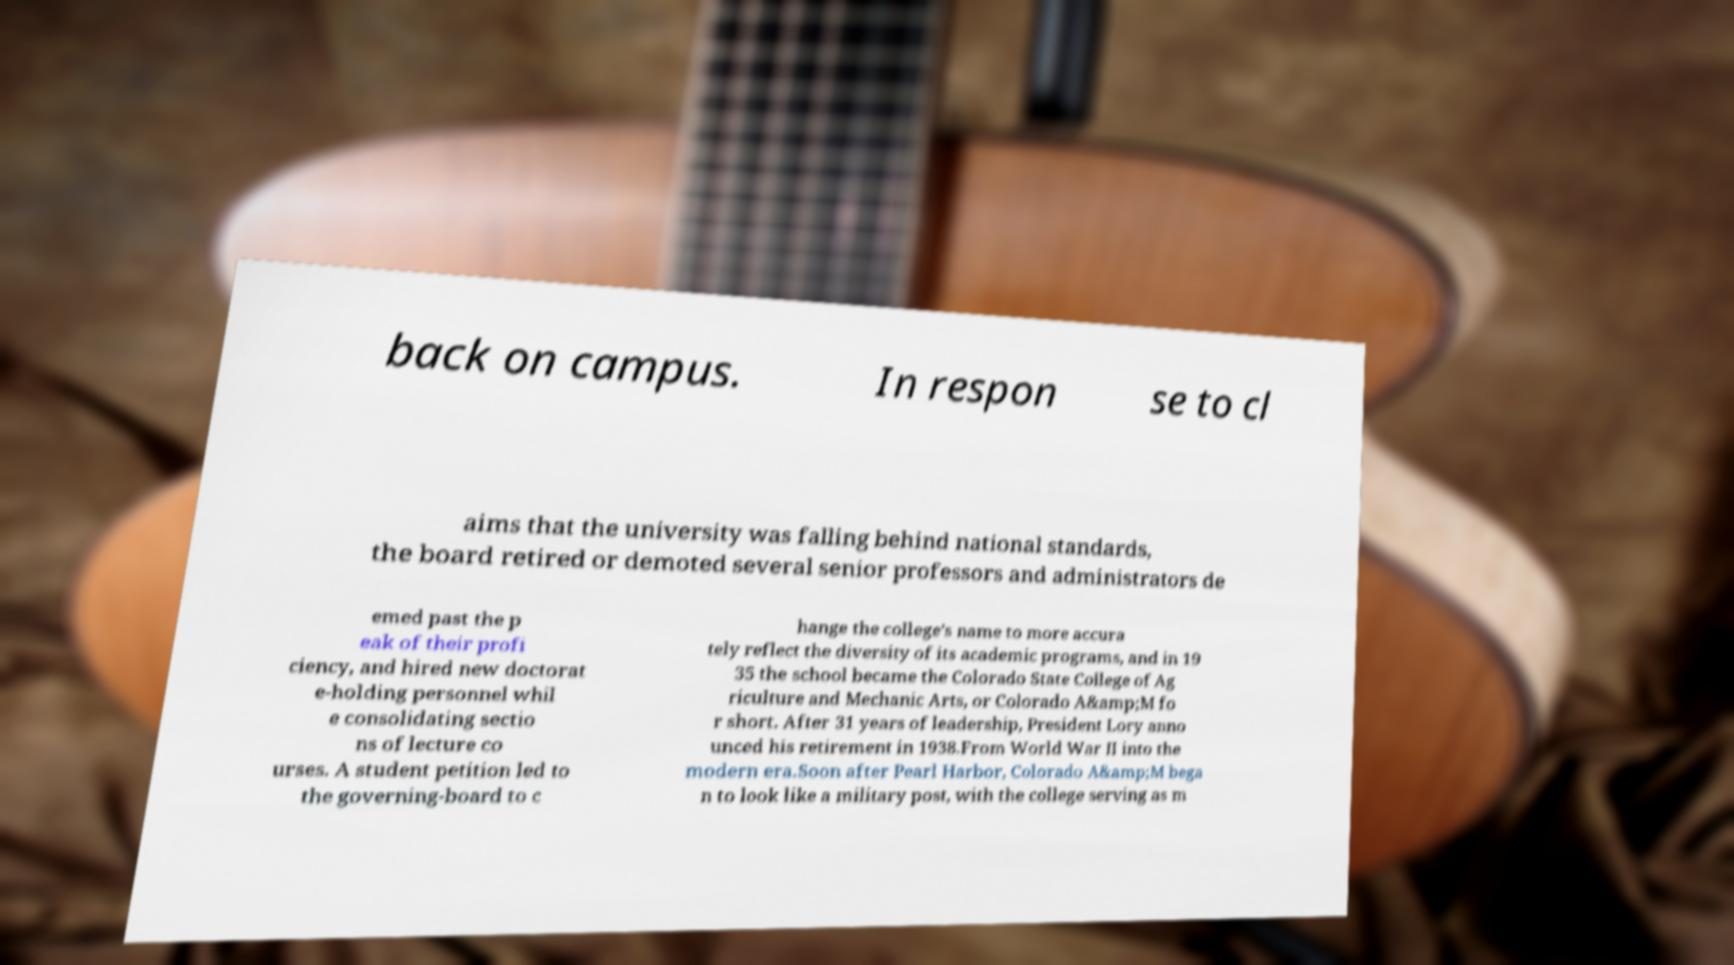Could you extract and type out the text from this image? back on campus. In respon se to cl aims that the university was falling behind national standards, the board retired or demoted several senior professors and administrators de emed past the p eak of their profi ciency, and hired new doctorat e-holding personnel whil e consolidating sectio ns of lecture co urses. A student petition led to the governing-board to c hange the college's name to more accura tely reflect the diversity of its academic programs, and in 19 35 the school became the Colorado State College of Ag riculture and Mechanic Arts, or Colorado A&amp;M fo r short. After 31 years of leadership, President Lory anno unced his retirement in 1938.From World War II into the modern era.Soon after Pearl Harbor, Colorado A&amp;M bega n to look like a military post, with the college serving as m 